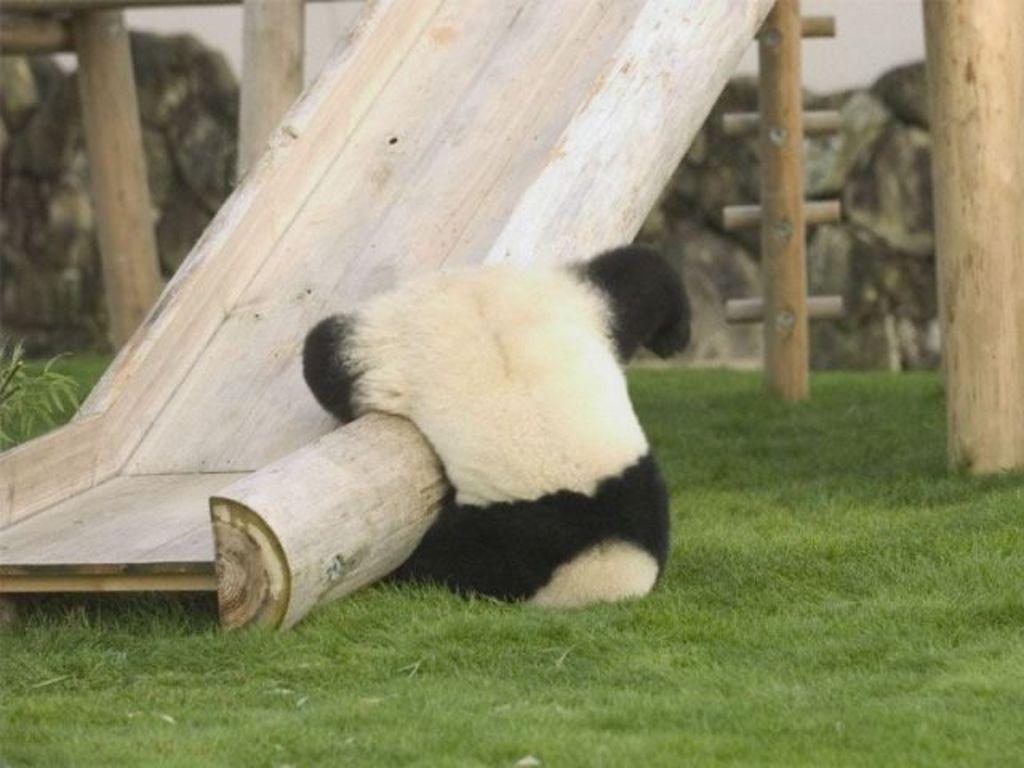Describe this image in one or two sentences. In this image, we can see the panda. We can also see the wooden slide. We can see some poles. We can also see the ground covered with grass. We can also see the wall. 